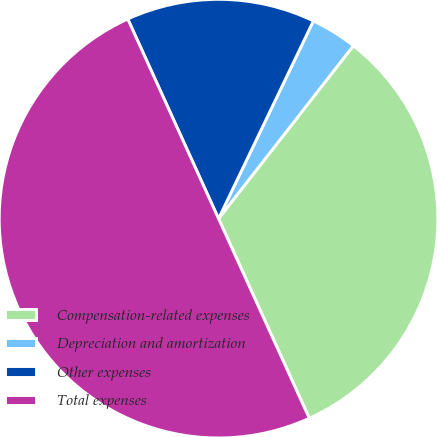Convert chart to OTSL. <chart><loc_0><loc_0><loc_500><loc_500><pie_chart><fcel>Compensation-related expenses<fcel>Depreciation and amortization<fcel>Other expenses<fcel>Total expenses<nl><fcel>32.67%<fcel>3.42%<fcel>13.91%<fcel>50.0%<nl></chart> 